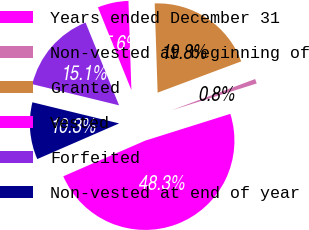Convert chart to OTSL. <chart><loc_0><loc_0><loc_500><loc_500><pie_chart><fcel>Years ended December 31<fcel>Non-vested at beginning of<fcel>Granted<fcel>Vested<fcel>Forfeited<fcel>Non-vested at end of year<nl><fcel>48.32%<fcel>0.84%<fcel>19.83%<fcel>5.59%<fcel>15.08%<fcel>10.34%<nl></chart> 